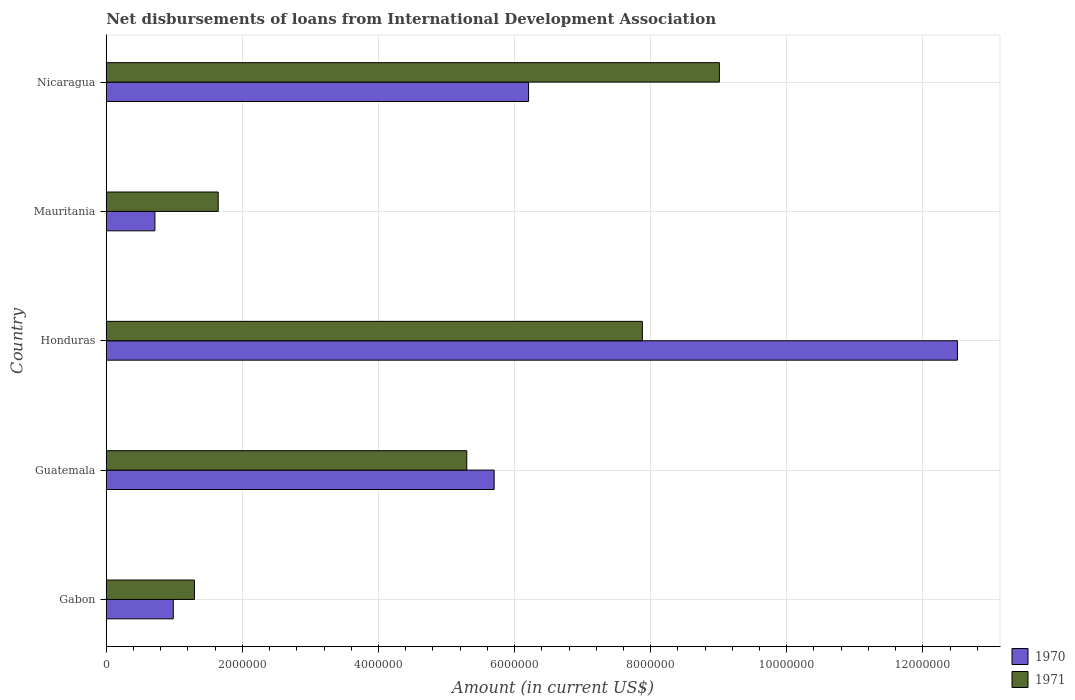How many different coloured bars are there?
Provide a short and direct response. 2. Are the number of bars per tick equal to the number of legend labels?
Your response must be concise. Yes. Are the number of bars on each tick of the Y-axis equal?
Your answer should be compact. Yes. How many bars are there on the 5th tick from the top?
Your answer should be very brief. 2. What is the label of the 1st group of bars from the top?
Ensure brevity in your answer.  Nicaragua. What is the amount of loans disbursed in 1971 in Guatemala?
Offer a terse response. 5.30e+06. Across all countries, what is the maximum amount of loans disbursed in 1971?
Your answer should be compact. 9.01e+06. Across all countries, what is the minimum amount of loans disbursed in 1970?
Keep it short and to the point. 7.15e+05. In which country was the amount of loans disbursed in 1970 maximum?
Your answer should be compact. Honduras. In which country was the amount of loans disbursed in 1971 minimum?
Your response must be concise. Gabon. What is the total amount of loans disbursed in 1971 in the graph?
Provide a succinct answer. 2.51e+07. What is the difference between the amount of loans disbursed in 1971 in Guatemala and that in Mauritania?
Your answer should be very brief. 3.65e+06. What is the difference between the amount of loans disbursed in 1970 in Nicaragua and the amount of loans disbursed in 1971 in Gabon?
Keep it short and to the point. 4.91e+06. What is the average amount of loans disbursed in 1971 per country?
Your answer should be very brief. 5.03e+06. What is the difference between the amount of loans disbursed in 1971 and amount of loans disbursed in 1970 in Mauritania?
Give a very brief answer. 9.30e+05. In how many countries, is the amount of loans disbursed in 1970 greater than 4000000 US$?
Your response must be concise. 3. What is the ratio of the amount of loans disbursed in 1971 in Gabon to that in Guatemala?
Provide a succinct answer. 0.24. Is the amount of loans disbursed in 1970 in Gabon less than that in Guatemala?
Your answer should be compact. Yes. Is the difference between the amount of loans disbursed in 1971 in Honduras and Mauritania greater than the difference between the amount of loans disbursed in 1970 in Honduras and Mauritania?
Make the answer very short. No. What is the difference between the highest and the second highest amount of loans disbursed in 1971?
Give a very brief answer. 1.13e+06. What is the difference between the highest and the lowest amount of loans disbursed in 1971?
Offer a terse response. 7.71e+06. What does the 2nd bar from the top in Honduras represents?
Your response must be concise. 1970. What does the 2nd bar from the bottom in Honduras represents?
Make the answer very short. 1971. How many bars are there?
Provide a short and direct response. 10. Are all the bars in the graph horizontal?
Offer a terse response. Yes. What is the difference between two consecutive major ticks on the X-axis?
Ensure brevity in your answer.  2.00e+06. Are the values on the major ticks of X-axis written in scientific E-notation?
Offer a terse response. No. Does the graph contain any zero values?
Your response must be concise. No. Does the graph contain grids?
Make the answer very short. Yes. How are the legend labels stacked?
Give a very brief answer. Vertical. What is the title of the graph?
Make the answer very short. Net disbursements of loans from International Development Association. What is the Amount (in current US$) in 1970 in Gabon?
Your answer should be compact. 9.85e+05. What is the Amount (in current US$) in 1971 in Gabon?
Keep it short and to the point. 1.30e+06. What is the Amount (in current US$) of 1970 in Guatemala?
Your response must be concise. 5.70e+06. What is the Amount (in current US$) in 1971 in Guatemala?
Your response must be concise. 5.30e+06. What is the Amount (in current US$) in 1970 in Honduras?
Offer a very short reply. 1.25e+07. What is the Amount (in current US$) in 1971 in Honduras?
Provide a short and direct response. 7.88e+06. What is the Amount (in current US$) in 1970 in Mauritania?
Keep it short and to the point. 7.15e+05. What is the Amount (in current US$) of 1971 in Mauritania?
Your answer should be very brief. 1.64e+06. What is the Amount (in current US$) in 1970 in Nicaragua?
Offer a very short reply. 6.21e+06. What is the Amount (in current US$) of 1971 in Nicaragua?
Give a very brief answer. 9.01e+06. Across all countries, what is the maximum Amount (in current US$) in 1970?
Your answer should be very brief. 1.25e+07. Across all countries, what is the maximum Amount (in current US$) in 1971?
Make the answer very short. 9.01e+06. Across all countries, what is the minimum Amount (in current US$) in 1970?
Provide a succinct answer. 7.15e+05. Across all countries, what is the minimum Amount (in current US$) of 1971?
Provide a short and direct response. 1.30e+06. What is the total Amount (in current US$) of 1970 in the graph?
Ensure brevity in your answer.  2.61e+07. What is the total Amount (in current US$) of 1971 in the graph?
Make the answer very short. 2.51e+07. What is the difference between the Amount (in current US$) of 1970 in Gabon and that in Guatemala?
Provide a succinct answer. -4.72e+06. What is the difference between the Amount (in current US$) of 1971 in Gabon and that in Guatemala?
Offer a very short reply. -4.00e+06. What is the difference between the Amount (in current US$) of 1970 in Gabon and that in Honduras?
Your answer should be very brief. -1.15e+07. What is the difference between the Amount (in current US$) of 1971 in Gabon and that in Honduras?
Offer a very short reply. -6.58e+06. What is the difference between the Amount (in current US$) of 1970 in Gabon and that in Mauritania?
Give a very brief answer. 2.70e+05. What is the difference between the Amount (in current US$) in 1971 in Gabon and that in Mauritania?
Your response must be concise. -3.49e+05. What is the difference between the Amount (in current US$) of 1970 in Gabon and that in Nicaragua?
Your answer should be compact. -5.22e+06. What is the difference between the Amount (in current US$) in 1971 in Gabon and that in Nicaragua?
Your answer should be very brief. -7.71e+06. What is the difference between the Amount (in current US$) in 1970 in Guatemala and that in Honduras?
Provide a short and direct response. -6.81e+06. What is the difference between the Amount (in current US$) in 1971 in Guatemala and that in Honduras?
Offer a very short reply. -2.58e+06. What is the difference between the Amount (in current US$) in 1970 in Guatemala and that in Mauritania?
Offer a very short reply. 4.98e+06. What is the difference between the Amount (in current US$) of 1971 in Guatemala and that in Mauritania?
Provide a succinct answer. 3.65e+06. What is the difference between the Amount (in current US$) in 1970 in Guatemala and that in Nicaragua?
Give a very brief answer. -5.06e+05. What is the difference between the Amount (in current US$) of 1971 in Guatemala and that in Nicaragua?
Give a very brief answer. -3.71e+06. What is the difference between the Amount (in current US$) of 1970 in Honduras and that in Mauritania?
Provide a succinct answer. 1.18e+07. What is the difference between the Amount (in current US$) of 1971 in Honduras and that in Mauritania?
Provide a succinct answer. 6.23e+06. What is the difference between the Amount (in current US$) of 1970 in Honduras and that in Nicaragua?
Make the answer very short. 6.30e+06. What is the difference between the Amount (in current US$) of 1971 in Honduras and that in Nicaragua?
Ensure brevity in your answer.  -1.13e+06. What is the difference between the Amount (in current US$) of 1970 in Mauritania and that in Nicaragua?
Give a very brief answer. -5.49e+06. What is the difference between the Amount (in current US$) in 1971 in Mauritania and that in Nicaragua?
Keep it short and to the point. -7.36e+06. What is the difference between the Amount (in current US$) in 1970 in Gabon and the Amount (in current US$) in 1971 in Guatemala?
Offer a very short reply. -4.31e+06. What is the difference between the Amount (in current US$) of 1970 in Gabon and the Amount (in current US$) of 1971 in Honduras?
Your answer should be compact. -6.89e+06. What is the difference between the Amount (in current US$) in 1970 in Gabon and the Amount (in current US$) in 1971 in Mauritania?
Your response must be concise. -6.60e+05. What is the difference between the Amount (in current US$) of 1970 in Gabon and the Amount (in current US$) of 1971 in Nicaragua?
Offer a very short reply. -8.02e+06. What is the difference between the Amount (in current US$) of 1970 in Guatemala and the Amount (in current US$) of 1971 in Honduras?
Your answer should be compact. -2.18e+06. What is the difference between the Amount (in current US$) of 1970 in Guatemala and the Amount (in current US$) of 1971 in Mauritania?
Keep it short and to the point. 4.06e+06. What is the difference between the Amount (in current US$) of 1970 in Guatemala and the Amount (in current US$) of 1971 in Nicaragua?
Ensure brevity in your answer.  -3.31e+06. What is the difference between the Amount (in current US$) of 1970 in Honduras and the Amount (in current US$) of 1971 in Mauritania?
Offer a terse response. 1.09e+07. What is the difference between the Amount (in current US$) of 1970 in Honduras and the Amount (in current US$) of 1971 in Nicaragua?
Offer a very short reply. 3.50e+06. What is the difference between the Amount (in current US$) in 1970 in Mauritania and the Amount (in current US$) in 1971 in Nicaragua?
Make the answer very short. -8.30e+06. What is the average Amount (in current US$) in 1970 per country?
Provide a succinct answer. 5.22e+06. What is the average Amount (in current US$) in 1971 per country?
Your answer should be very brief. 5.03e+06. What is the difference between the Amount (in current US$) of 1970 and Amount (in current US$) of 1971 in Gabon?
Provide a succinct answer. -3.11e+05. What is the difference between the Amount (in current US$) in 1970 and Amount (in current US$) in 1971 in Guatemala?
Provide a short and direct response. 4.02e+05. What is the difference between the Amount (in current US$) in 1970 and Amount (in current US$) in 1971 in Honduras?
Keep it short and to the point. 4.63e+06. What is the difference between the Amount (in current US$) in 1970 and Amount (in current US$) in 1971 in Mauritania?
Make the answer very short. -9.30e+05. What is the difference between the Amount (in current US$) of 1970 and Amount (in current US$) of 1971 in Nicaragua?
Provide a short and direct response. -2.80e+06. What is the ratio of the Amount (in current US$) in 1970 in Gabon to that in Guatemala?
Your answer should be compact. 0.17. What is the ratio of the Amount (in current US$) of 1971 in Gabon to that in Guatemala?
Your answer should be compact. 0.24. What is the ratio of the Amount (in current US$) in 1970 in Gabon to that in Honduras?
Provide a succinct answer. 0.08. What is the ratio of the Amount (in current US$) of 1971 in Gabon to that in Honduras?
Provide a succinct answer. 0.16. What is the ratio of the Amount (in current US$) of 1970 in Gabon to that in Mauritania?
Provide a short and direct response. 1.38. What is the ratio of the Amount (in current US$) in 1971 in Gabon to that in Mauritania?
Ensure brevity in your answer.  0.79. What is the ratio of the Amount (in current US$) of 1970 in Gabon to that in Nicaragua?
Keep it short and to the point. 0.16. What is the ratio of the Amount (in current US$) of 1971 in Gabon to that in Nicaragua?
Provide a succinct answer. 0.14. What is the ratio of the Amount (in current US$) in 1970 in Guatemala to that in Honduras?
Keep it short and to the point. 0.46. What is the ratio of the Amount (in current US$) in 1971 in Guatemala to that in Honduras?
Keep it short and to the point. 0.67. What is the ratio of the Amount (in current US$) in 1970 in Guatemala to that in Mauritania?
Keep it short and to the point. 7.97. What is the ratio of the Amount (in current US$) in 1971 in Guatemala to that in Mauritania?
Keep it short and to the point. 3.22. What is the ratio of the Amount (in current US$) of 1970 in Guatemala to that in Nicaragua?
Provide a succinct answer. 0.92. What is the ratio of the Amount (in current US$) in 1971 in Guatemala to that in Nicaragua?
Give a very brief answer. 0.59. What is the ratio of the Amount (in current US$) of 1970 in Honduras to that in Mauritania?
Make the answer very short. 17.49. What is the ratio of the Amount (in current US$) of 1971 in Honduras to that in Mauritania?
Offer a terse response. 4.79. What is the ratio of the Amount (in current US$) of 1970 in Honduras to that in Nicaragua?
Provide a short and direct response. 2.02. What is the ratio of the Amount (in current US$) of 1971 in Honduras to that in Nicaragua?
Your response must be concise. 0.87. What is the ratio of the Amount (in current US$) of 1970 in Mauritania to that in Nicaragua?
Keep it short and to the point. 0.12. What is the ratio of the Amount (in current US$) of 1971 in Mauritania to that in Nicaragua?
Provide a succinct answer. 0.18. What is the difference between the highest and the second highest Amount (in current US$) in 1970?
Provide a succinct answer. 6.30e+06. What is the difference between the highest and the second highest Amount (in current US$) in 1971?
Your answer should be very brief. 1.13e+06. What is the difference between the highest and the lowest Amount (in current US$) of 1970?
Provide a succinct answer. 1.18e+07. What is the difference between the highest and the lowest Amount (in current US$) of 1971?
Make the answer very short. 7.71e+06. 